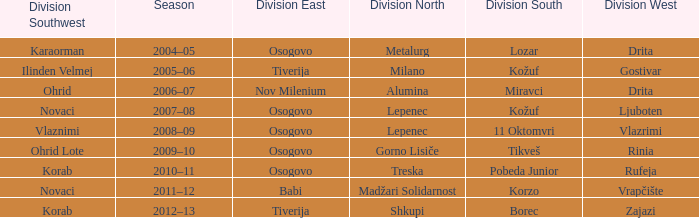Who won Division Southwest when the winner of Division North was Lepenec and Division South was won by 11 Oktomvri? Vlaznimi. 